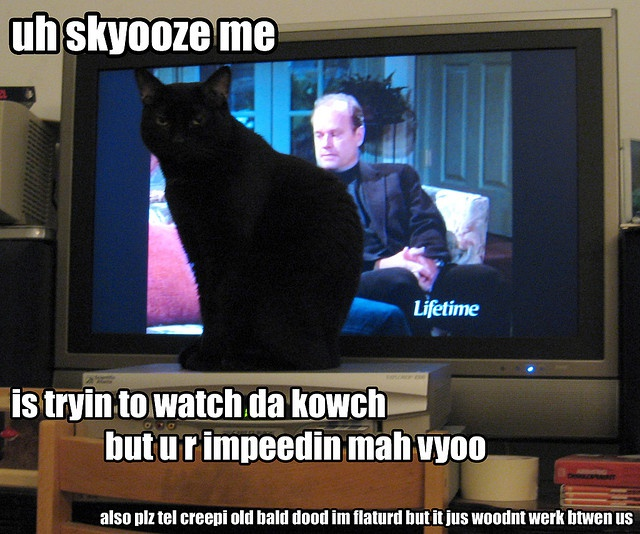Describe the objects in this image and their specific colors. I can see tv in tan, black, navy, and blue tones, cat in tan, black, navy, and blue tones, chair in tan, maroon, white, and brown tones, people in tan, black, navy, lavender, and violet tones, and couch in tan, white, violet, darkgray, and magenta tones in this image. 